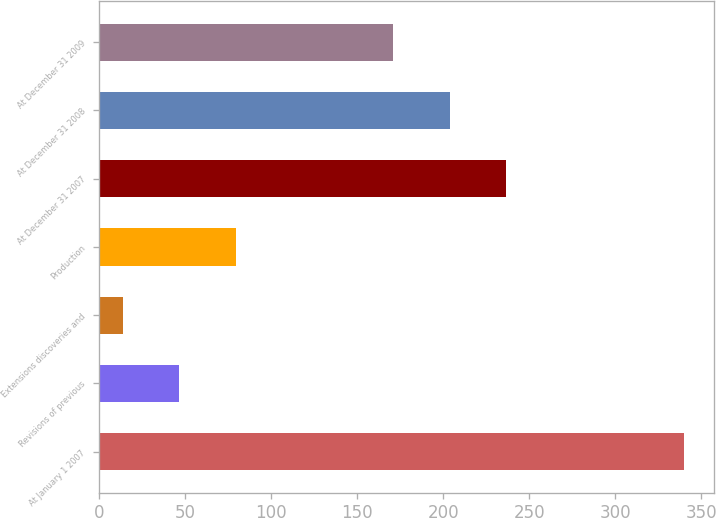<chart> <loc_0><loc_0><loc_500><loc_500><bar_chart><fcel>At January 1 2007<fcel>Revisions of previous<fcel>Extensions discoveries and<fcel>Production<fcel>At December 31 2007<fcel>At December 31 2008<fcel>At December 31 2009<nl><fcel>340<fcel>46.6<fcel>14<fcel>79.2<fcel>236.2<fcel>203.6<fcel>171<nl></chart> 